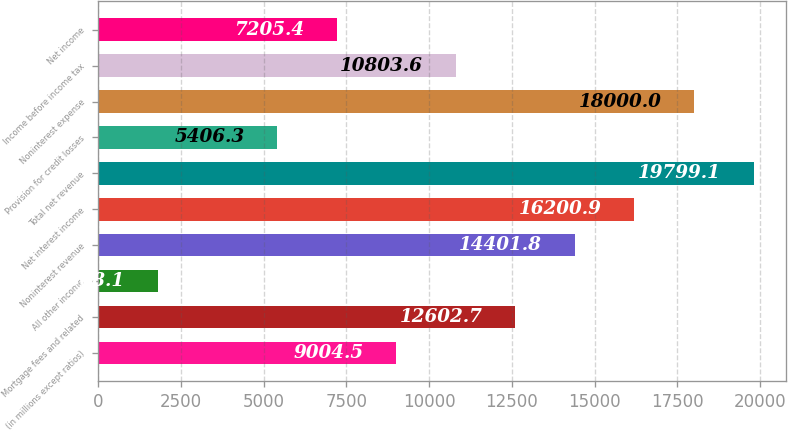Convert chart to OTSL. <chart><loc_0><loc_0><loc_500><loc_500><bar_chart><fcel>(in millions except ratios)<fcel>Mortgage fees and related<fcel>All other income<fcel>Noninterest revenue<fcel>Net interest income<fcel>Total net revenue<fcel>Provision for credit losses<fcel>Noninterest expense<fcel>Income before income tax<fcel>Net income<nl><fcel>9004.5<fcel>12602.7<fcel>1808.1<fcel>14401.8<fcel>16200.9<fcel>19799.1<fcel>5406.3<fcel>18000<fcel>10803.6<fcel>7205.4<nl></chart> 